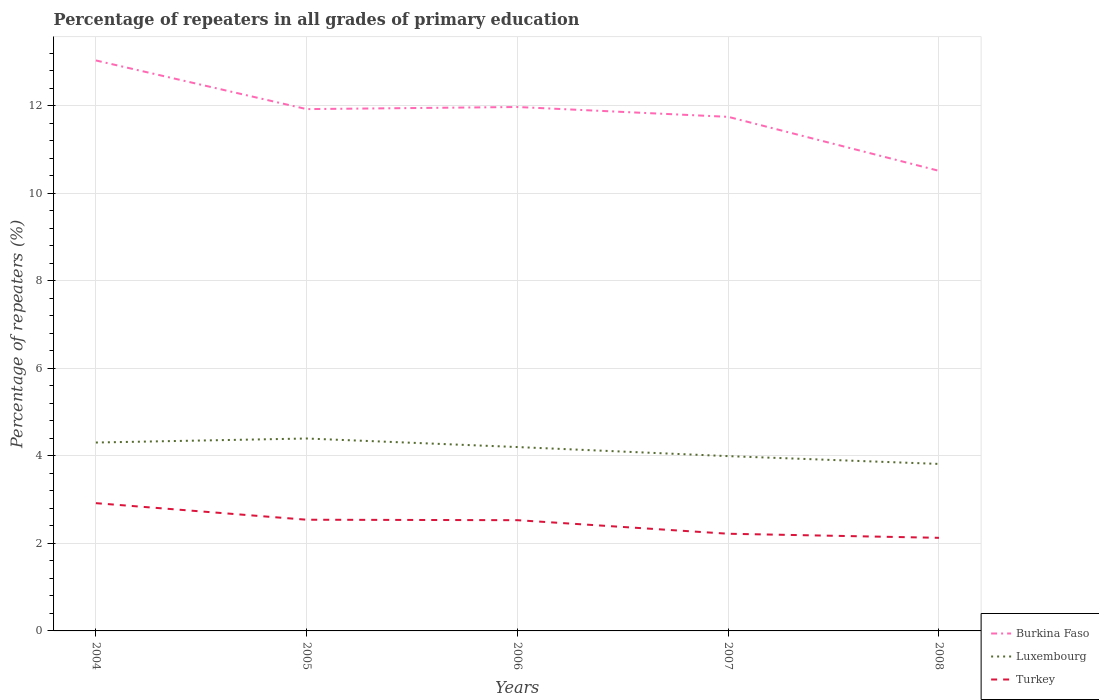How many different coloured lines are there?
Provide a short and direct response. 3. Is the number of lines equal to the number of legend labels?
Provide a short and direct response. Yes. Across all years, what is the maximum percentage of repeaters in Turkey?
Provide a succinct answer. 2.13. In which year was the percentage of repeaters in Turkey maximum?
Provide a succinct answer. 2008. What is the total percentage of repeaters in Luxembourg in the graph?
Give a very brief answer. -0.09. What is the difference between the highest and the second highest percentage of repeaters in Luxembourg?
Keep it short and to the point. 0.58. How many years are there in the graph?
Your response must be concise. 5. What is the difference between two consecutive major ticks on the Y-axis?
Ensure brevity in your answer.  2. Where does the legend appear in the graph?
Provide a short and direct response. Bottom right. How many legend labels are there?
Ensure brevity in your answer.  3. How are the legend labels stacked?
Provide a succinct answer. Vertical. What is the title of the graph?
Offer a very short reply. Percentage of repeaters in all grades of primary education. Does "Iran" appear as one of the legend labels in the graph?
Your answer should be very brief. No. What is the label or title of the Y-axis?
Your answer should be compact. Percentage of repeaters (%). What is the Percentage of repeaters (%) in Burkina Faso in 2004?
Ensure brevity in your answer.  13.04. What is the Percentage of repeaters (%) in Luxembourg in 2004?
Provide a short and direct response. 4.31. What is the Percentage of repeaters (%) in Turkey in 2004?
Keep it short and to the point. 2.92. What is the Percentage of repeaters (%) in Burkina Faso in 2005?
Provide a succinct answer. 11.93. What is the Percentage of repeaters (%) of Luxembourg in 2005?
Your answer should be compact. 4.4. What is the Percentage of repeaters (%) in Turkey in 2005?
Your response must be concise. 2.54. What is the Percentage of repeaters (%) of Burkina Faso in 2006?
Provide a succinct answer. 11.98. What is the Percentage of repeaters (%) in Luxembourg in 2006?
Your answer should be very brief. 4.2. What is the Percentage of repeaters (%) in Turkey in 2006?
Provide a succinct answer. 2.53. What is the Percentage of repeaters (%) of Burkina Faso in 2007?
Give a very brief answer. 11.75. What is the Percentage of repeaters (%) in Luxembourg in 2007?
Ensure brevity in your answer.  4. What is the Percentage of repeaters (%) of Turkey in 2007?
Give a very brief answer. 2.22. What is the Percentage of repeaters (%) of Burkina Faso in 2008?
Give a very brief answer. 10.52. What is the Percentage of repeaters (%) of Luxembourg in 2008?
Ensure brevity in your answer.  3.82. What is the Percentage of repeaters (%) in Turkey in 2008?
Ensure brevity in your answer.  2.13. Across all years, what is the maximum Percentage of repeaters (%) in Burkina Faso?
Your answer should be compact. 13.04. Across all years, what is the maximum Percentage of repeaters (%) in Luxembourg?
Your answer should be very brief. 4.4. Across all years, what is the maximum Percentage of repeaters (%) in Turkey?
Your answer should be compact. 2.92. Across all years, what is the minimum Percentage of repeaters (%) of Burkina Faso?
Make the answer very short. 10.52. Across all years, what is the minimum Percentage of repeaters (%) of Luxembourg?
Provide a short and direct response. 3.82. Across all years, what is the minimum Percentage of repeaters (%) of Turkey?
Offer a very short reply. 2.13. What is the total Percentage of repeaters (%) in Burkina Faso in the graph?
Offer a very short reply. 59.21. What is the total Percentage of repeaters (%) of Luxembourg in the graph?
Make the answer very short. 20.72. What is the total Percentage of repeaters (%) in Turkey in the graph?
Your answer should be compact. 12.34. What is the difference between the Percentage of repeaters (%) of Burkina Faso in 2004 and that in 2005?
Give a very brief answer. 1.11. What is the difference between the Percentage of repeaters (%) in Luxembourg in 2004 and that in 2005?
Provide a succinct answer. -0.09. What is the difference between the Percentage of repeaters (%) of Turkey in 2004 and that in 2005?
Make the answer very short. 0.38. What is the difference between the Percentage of repeaters (%) of Burkina Faso in 2004 and that in 2006?
Keep it short and to the point. 1.06. What is the difference between the Percentage of repeaters (%) of Luxembourg in 2004 and that in 2006?
Make the answer very short. 0.1. What is the difference between the Percentage of repeaters (%) of Turkey in 2004 and that in 2006?
Your answer should be compact. 0.39. What is the difference between the Percentage of repeaters (%) in Burkina Faso in 2004 and that in 2007?
Give a very brief answer. 1.29. What is the difference between the Percentage of repeaters (%) in Luxembourg in 2004 and that in 2007?
Your answer should be very brief. 0.31. What is the difference between the Percentage of repeaters (%) in Turkey in 2004 and that in 2007?
Your answer should be very brief. 0.7. What is the difference between the Percentage of repeaters (%) of Burkina Faso in 2004 and that in 2008?
Provide a short and direct response. 2.52. What is the difference between the Percentage of repeaters (%) in Luxembourg in 2004 and that in 2008?
Your answer should be very brief. 0.49. What is the difference between the Percentage of repeaters (%) in Turkey in 2004 and that in 2008?
Keep it short and to the point. 0.79. What is the difference between the Percentage of repeaters (%) of Burkina Faso in 2005 and that in 2006?
Offer a terse response. -0.05. What is the difference between the Percentage of repeaters (%) of Luxembourg in 2005 and that in 2006?
Your response must be concise. 0.2. What is the difference between the Percentage of repeaters (%) of Turkey in 2005 and that in 2006?
Your answer should be very brief. 0.01. What is the difference between the Percentage of repeaters (%) in Burkina Faso in 2005 and that in 2007?
Your response must be concise. 0.18. What is the difference between the Percentage of repeaters (%) in Luxembourg in 2005 and that in 2007?
Ensure brevity in your answer.  0.4. What is the difference between the Percentage of repeaters (%) of Turkey in 2005 and that in 2007?
Offer a very short reply. 0.32. What is the difference between the Percentage of repeaters (%) in Burkina Faso in 2005 and that in 2008?
Offer a very short reply. 1.41. What is the difference between the Percentage of repeaters (%) of Luxembourg in 2005 and that in 2008?
Your answer should be compact. 0.58. What is the difference between the Percentage of repeaters (%) of Turkey in 2005 and that in 2008?
Make the answer very short. 0.41. What is the difference between the Percentage of repeaters (%) of Burkina Faso in 2006 and that in 2007?
Offer a very short reply. 0.23. What is the difference between the Percentage of repeaters (%) in Luxembourg in 2006 and that in 2007?
Your response must be concise. 0.21. What is the difference between the Percentage of repeaters (%) of Turkey in 2006 and that in 2007?
Make the answer very short. 0.31. What is the difference between the Percentage of repeaters (%) in Burkina Faso in 2006 and that in 2008?
Provide a succinct answer. 1.46. What is the difference between the Percentage of repeaters (%) of Luxembourg in 2006 and that in 2008?
Offer a very short reply. 0.39. What is the difference between the Percentage of repeaters (%) in Turkey in 2006 and that in 2008?
Your answer should be very brief. 0.4. What is the difference between the Percentage of repeaters (%) in Burkina Faso in 2007 and that in 2008?
Offer a very short reply. 1.23. What is the difference between the Percentage of repeaters (%) in Luxembourg in 2007 and that in 2008?
Provide a succinct answer. 0.18. What is the difference between the Percentage of repeaters (%) of Turkey in 2007 and that in 2008?
Offer a very short reply. 0.09. What is the difference between the Percentage of repeaters (%) in Burkina Faso in 2004 and the Percentage of repeaters (%) in Luxembourg in 2005?
Offer a very short reply. 8.64. What is the difference between the Percentage of repeaters (%) of Burkina Faso in 2004 and the Percentage of repeaters (%) of Turkey in 2005?
Keep it short and to the point. 10.5. What is the difference between the Percentage of repeaters (%) in Luxembourg in 2004 and the Percentage of repeaters (%) in Turkey in 2005?
Your response must be concise. 1.76. What is the difference between the Percentage of repeaters (%) of Burkina Faso in 2004 and the Percentage of repeaters (%) of Luxembourg in 2006?
Keep it short and to the point. 8.84. What is the difference between the Percentage of repeaters (%) of Burkina Faso in 2004 and the Percentage of repeaters (%) of Turkey in 2006?
Your answer should be compact. 10.51. What is the difference between the Percentage of repeaters (%) of Luxembourg in 2004 and the Percentage of repeaters (%) of Turkey in 2006?
Your response must be concise. 1.77. What is the difference between the Percentage of repeaters (%) in Burkina Faso in 2004 and the Percentage of repeaters (%) in Luxembourg in 2007?
Offer a very short reply. 9.04. What is the difference between the Percentage of repeaters (%) in Burkina Faso in 2004 and the Percentage of repeaters (%) in Turkey in 2007?
Keep it short and to the point. 10.82. What is the difference between the Percentage of repeaters (%) of Luxembourg in 2004 and the Percentage of repeaters (%) of Turkey in 2007?
Provide a succinct answer. 2.08. What is the difference between the Percentage of repeaters (%) of Burkina Faso in 2004 and the Percentage of repeaters (%) of Luxembourg in 2008?
Offer a terse response. 9.22. What is the difference between the Percentage of repeaters (%) of Burkina Faso in 2004 and the Percentage of repeaters (%) of Turkey in 2008?
Provide a succinct answer. 10.91. What is the difference between the Percentage of repeaters (%) of Luxembourg in 2004 and the Percentage of repeaters (%) of Turkey in 2008?
Your answer should be very brief. 2.18. What is the difference between the Percentage of repeaters (%) in Burkina Faso in 2005 and the Percentage of repeaters (%) in Luxembourg in 2006?
Offer a very short reply. 7.72. What is the difference between the Percentage of repeaters (%) of Burkina Faso in 2005 and the Percentage of repeaters (%) of Turkey in 2006?
Ensure brevity in your answer.  9.4. What is the difference between the Percentage of repeaters (%) of Luxembourg in 2005 and the Percentage of repeaters (%) of Turkey in 2006?
Keep it short and to the point. 1.87. What is the difference between the Percentage of repeaters (%) in Burkina Faso in 2005 and the Percentage of repeaters (%) in Luxembourg in 2007?
Make the answer very short. 7.93. What is the difference between the Percentage of repeaters (%) of Burkina Faso in 2005 and the Percentage of repeaters (%) of Turkey in 2007?
Ensure brevity in your answer.  9.71. What is the difference between the Percentage of repeaters (%) in Luxembourg in 2005 and the Percentage of repeaters (%) in Turkey in 2007?
Provide a succinct answer. 2.18. What is the difference between the Percentage of repeaters (%) in Burkina Faso in 2005 and the Percentage of repeaters (%) in Luxembourg in 2008?
Ensure brevity in your answer.  8.11. What is the difference between the Percentage of repeaters (%) in Burkina Faso in 2005 and the Percentage of repeaters (%) in Turkey in 2008?
Provide a succinct answer. 9.8. What is the difference between the Percentage of repeaters (%) of Luxembourg in 2005 and the Percentage of repeaters (%) of Turkey in 2008?
Offer a terse response. 2.27. What is the difference between the Percentage of repeaters (%) of Burkina Faso in 2006 and the Percentage of repeaters (%) of Luxembourg in 2007?
Keep it short and to the point. 7.98. What is the difference between the Percentage of repeaters (%) in Burkina Faso in 2006 and the Percentage of repeaters (%) in Turkey in 2007?
Offer a very short reply. 9.75. What is the difference between the Percentage of repeaters (%) in Luxembourg in 2006 and the Percentage of repeaters (%) in Turkey in 2007?
Your answer should be compact. 1.98. What is the difference between the Percentage of repeaters (%) in Burkina Faso in 2006 and the Percentage of repeaters (%) in Luxembourg in 2008?
Ensure brevity in your answer.  8.16. What is the difference between the Percentage of repeaters (%) in Burkina Faso in 2006 and the Percentage of repeaters (%) in Turkey in 2008?
Offer a terse response. 9.85. What is the difference between the Percentage of repeaters (%) in Luxembourg in 2006 and the Percentage of repeaters (%) in Turkey in 2008?
Offer a terse response. 2.07. What is the difference between the Percentage of repeaters (%) of Burkina Faso in 2007 and the Percentage of repeaters (%) of Luxembourg in 2008?
Provide a succinct answer. 7.93. What is the difference between the Percentage of repeaters (%) in Burkina Faso in 2007 and the Percentage of repeaters (%) in Turkey in 2008?
Keep it short and to the point. 9.62. What is the difference between the Percentage of repeaters (%) of Luxembourg in 2007 and the Percentage of repeaters (%) of Turkey in 2008?
Offer a terse response. 1.87. What is the average Percentage of repeaters (%) of Burkina Faso per year?
Give a very brief answer. 11.84. What is the average Percentage of repeaters (%) in Luxembourg per year?
Your response must be concise. 4.14. What is the average Percentage of repeaters (%) of Turkey per year?
Keep it short and to the point. 2.47. In the year 2004, what is the difference between the Percentage of repeaters (%) of Burkina Faso and Percentage of repeaters (%) of Luxembourg?
Give a very brief answer. 8.73. In the year 2004, what is the difference between the Percentage of repeaters (%) in Burkina Faso and Percentage of repeaters (%) in Turkey?
Keep it short and to the point. 10.12. In the year 2004, what is the difference between the Percentage of repeaters (%) of Luxembourg and Percentage of repeaters (%) of Turkey?
Give a very brief answer. 1.39. In the year 2005, what is the difference between the Percentage of repeaters (%) of Burkina Faso and Percentage of repeaters (%) of Luxembourg?
Give a very brief answer. 7.53. In the year 2005, what is the difference between the Percentage of repeaters (%) of Burkina Faso and Percentage of repeaters (%) of Turkey?
Ensure brevity in your answer.  9.39. In the year 2005, what is the difference between the Percentage of repeaters (%) in Luxembourg and Percentage of repeaters (%) in Turkey?
Your answer should be compact. 1.86. In the year 2006, what is the difference between the Percentage of repeaters (%) of Burkina Faso and Percentage of repeaters (%) of Luxembourg?
Your answer should be compact. 7.77. In the year 2006, what is the difference between the Percentage of repeaters (%) in Burkina Faso and Percentage of repeaters (%) in Turkey?
Ensure brevity in your answer.  9.44. In the year 2006, what is the difference between the Percentage of repeaters (%) of Luxembourg and Percentage of repeaters (%) of Turkey?
Your answer should be compact. 1.67. In the year 2007, what is the difference between the Percentage of repeaters (%) in Burkina Faso and Percentage of repeaters (%) in Luxembourg?
Make the answer very short. 7.75. In the year 2007, what is the difference between the Percentage of repeaters (%) in Burkina Faso and Percentage of repeaters (%) in Turkey?
Keep it short and to the point. 9.53. In the year 2007, what is the difference between the Percentage of repeaters (%) of Luxembourg and Percentage of repeaters (%) of Turkey?
Your answer should be compact. 1.77. In the year 2008, what is the difference between the Percentage of repeaters (%) in Burkina Faso and Percentage of repeaters (%) in Luxembourg?
Your response must be concise. 6.7. In the year 2008, what is the difference between the Percentage of repeaters (%) in Burkina Faso and Percentage of repeaters (%) in Turkey?
Give a very brief answer. 8.39. In the year 2008, what is the difference between the Percentage of repeaters (%) in Luxembourg and Percentage of repeaters (%) in Turkey?
Your answer should be compact. 1.69. What is the ratio of the Percentage of repeaters (%) in Burkina Faso in 2004 to that in 2005?
Your response must be concise. 1.09. What is the ratio of the Percentage of repeaters (%) of Luxembourg in 2004 to that in 2005?
Your response must be concise. 0.98. What is the ratio of the Percentage of repeaters (%) in Turkey in 2004 to that in 2005?
Give a very brief answer. 1.15. What is the ratio of the Percentage of repeaters (%) of Burkina Faso in 2004 to that in 2006?
Provide a short and direct response. 1.09. What is the ratio of the Percentage of repeaters (%) in Luxembourg in 2004 to that in 2006?
Ensure brevity in your answer.  1.02. What is the ratio of the Percentage of repeaters (%) in Turkey in 2004 to that in 2006?
Your answer should be compact. 1.15. What is the ratio of the Percentage of repeaters (%) of Burkina Faso in 2004 to that in 2007?
Your response must be concise. 1.11. What is the ratio of the Percentage of repeaters (%) of Luxembourg in 2004 to that in 2007?
Give a very brief answer. 1.08. What is the ratio of the Percentage of repeaters (%) of Turkey in 2004 to that in 2007?
Ensure brevity in your answer.  1.31. What is the ratio of the Percentage of repeaters (%) in Burkina Faso in 2004 to that in 2008?
Your answer should be very brief. 1.24. What is the ratio of the Percentage of repeaters (%) in Luxembourg in 2004 to that in 2008?
Your answer should be very brief. 1.13. What is the ratio of the Percentage of repeaters (%) in Turkey in 2004 to that in 2008?
Provide a succinct answer. 1.37. What is the ratio of the Percentage of repeaters (%) of Luxembourg in 2005 to that in 2006?
Offer a terse response. 1.05. What is the ratio of the Percentage of repeaters (%) of Burkina Faso in 2005 to that in 2007?
Provide a succinct answer. 1.01. What is the ratio of the Percentage of repeaters (%) of Luxembourg in 2005 to that in 2007?
Keep it short and to the point. 1.1. What is the ratio of the Percentage of repeaters (%) in Turkey in 2005 to that in 2007?
Ensure brevity in your answer.  1.14. What is the ratio of the Percentage of repeaters (%) of Burkina Faso in 2005 to that in 2008?
Your answer should be very brief. 1.13. What is the ratio of the Percentage of repeaters (%) of Luxembourg in 2005 to that in 2008?
Your answer should be very brief. 1.15. What is the ratio of the Percentage of repeaters (%) of Turkey in 2005 to that in 2008?
Make the answer very short. 1.19. What is the ratio of the Percentage of repeaters (%) in Burkina Faso in 2006 to that in 2007?
Offer a very short reply. 1.02. What is the ratio of the Percentage of repeaters (%) in Luxembourg in 2006 to that in 2007?
Provide a succinct answer. 1.05. What is the ratio of the Percentage of repeaters (%) of Turkey in 2006 to that in 2007?
Your answer should be very brief. 1.14. What is the ratio of the Percentage of repeaters (%) in Burkina Faso in 2006 to that in 2008?
Make the answer very short. 1.14. What is the ratio of the Percentage of repeaters (%) in Luxembourg in 2006 to that in 2008?
Make the answer very short. 1.1. What is the ratio of the Percentage of repeaters (%) in Turkey in 2006 to that in 2008?
Your answer should be compact. 1.19. What is the ratio of the Percentage of repeaters (%) of Burkina Faso in 2007 to that in 2008?
Your answer should be very brief. 1.12. What is the ratio of the Percentage of repeaters (%) of Luxembourg in 2007 to that in 2008?
Make the answer very short. 1.05. What is the ratio of the Percentage of repeaters (%) in Turkey in 2007 to that in 2008?
Your response must be concise. 1.04. What is the difference between the highest and the second highest Percentage of repeaters (%) in Burkina Faso?
Your answer should be very brief. 1.06. What is the difference between the highest and the second highest Percentage of repeaters (%) in Luxembourg?
Your answer should be very brief. 0.09. What is the difference between the highest and the second highest Percentage of repeaters (%) in Turkey?
Your answer should be compact. 0.38. What is the difference between the highest and the lowest Percentage of repeaters (%) in Burkina Faso?
Ensure brevity in your answer.  2.52. What is the difference between the highest and the lowest Percentage of repeaters (%) in Luxembourg?
Provide a short and direct response. 0.58. What is the difference between the highest and the lowest Percentage of repeaters (%) in Turkey?
Offer a very short reply. 0.79. 